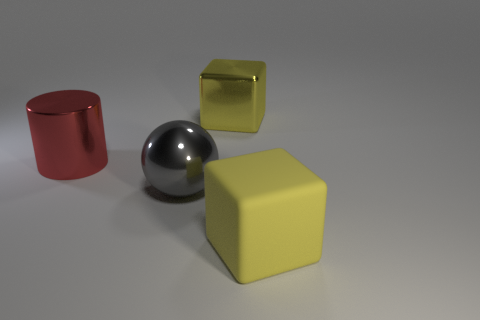Do the metal cube and the large matte object have the same color?
Provide a short and direct response. Yes. Do the block right of the big shiny block and the metallic cube have the same color?
Give a very brief answer. Yes. There is a big red thing that is the same material as the big gray object; what shape is it?
Your answer should be very brief. Cylinder. What color is the thing that is behind the metallic sphere and on the right side of the large sphere?
Your response must be concise. Yellow. Is there a cube that has the same color as the large rubber object?
Give a very brief answer. Yes. Are there the same number of large cubes in front of the gray metallic object and big yellow matte objects?
Your answer should be compact. Yes. How many yellow things are there?
Provide a short and direct response. 2. There is a object that is both to the right of the sphere and in front of the big shiny cylinder; what is its shape?
Ensure brevity in your answer.  Cube. Is the color of the big block that is in front of the big yellow metal thing the same as the big shiny thing that is to the right of the gray metallic sphere?
Give a very brief answer. Yes. There is a shiny cube that is the same color as the large matte block; what is its size?
Your answer should be compact. Large. 